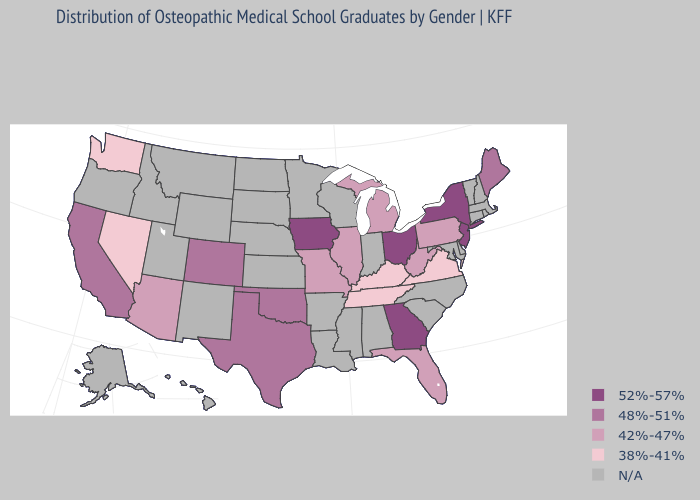Does Kentucky have the lowest value in the USA?
Keep it brief. Yes. Does the first symbol in the legend represent the smallest category?
Write a very short answer. No. Does Nevada have the highest value in the West?
Give a very brief answer. No. Which states have the highest value in the USA?
Concise answer only. Georgia, Iowa, New Jersey, New York, Ohio. Which states hav the highest value in the MidWest?
Write a very short answer. Iowa, Ohio. What is the value of Hawaii?
Give a very brief answer. N/A. Name the states that have a value in the range 48%-51%?
Keep it brief. California, Colorado, Maine, Oklahoma, Texas. Name the states that have a value in the range 52%-57%?
Be succinct. Georgia, Iowa, New Jersey, New York, Ohio. What is the value of Indiana?
Be succinct. N/A. Among the states that border Alabama , does Tennessee have the lowest value?
Keep it brief. Yes. Name the states that have a value in the range N/A?
Write a very short answer. Alabama, Alaska, Arkansas, Connecticut, Delaware, Hawaii, Idaho, Indiana, Kansas, Louisiana, Maryland, Massachusetts, Minnesota, Mississippi, Montana, Nebraska, New Hampshire, New Mexico, North Carolina, North Dakota, Oregon, Rhode Island, South Carolina, South Dakota, Utah, Vermont, Wisconsin, Wyoming. Among the states that border Alabama , does Florida have the lowest value?
Concise answer only. No. Among the states that border Virginia , does Tennessee have the lowest value?
Write a very short answer. Yes. Does Georgia have the lowest value in the USA?
Write a very short answer. No. 